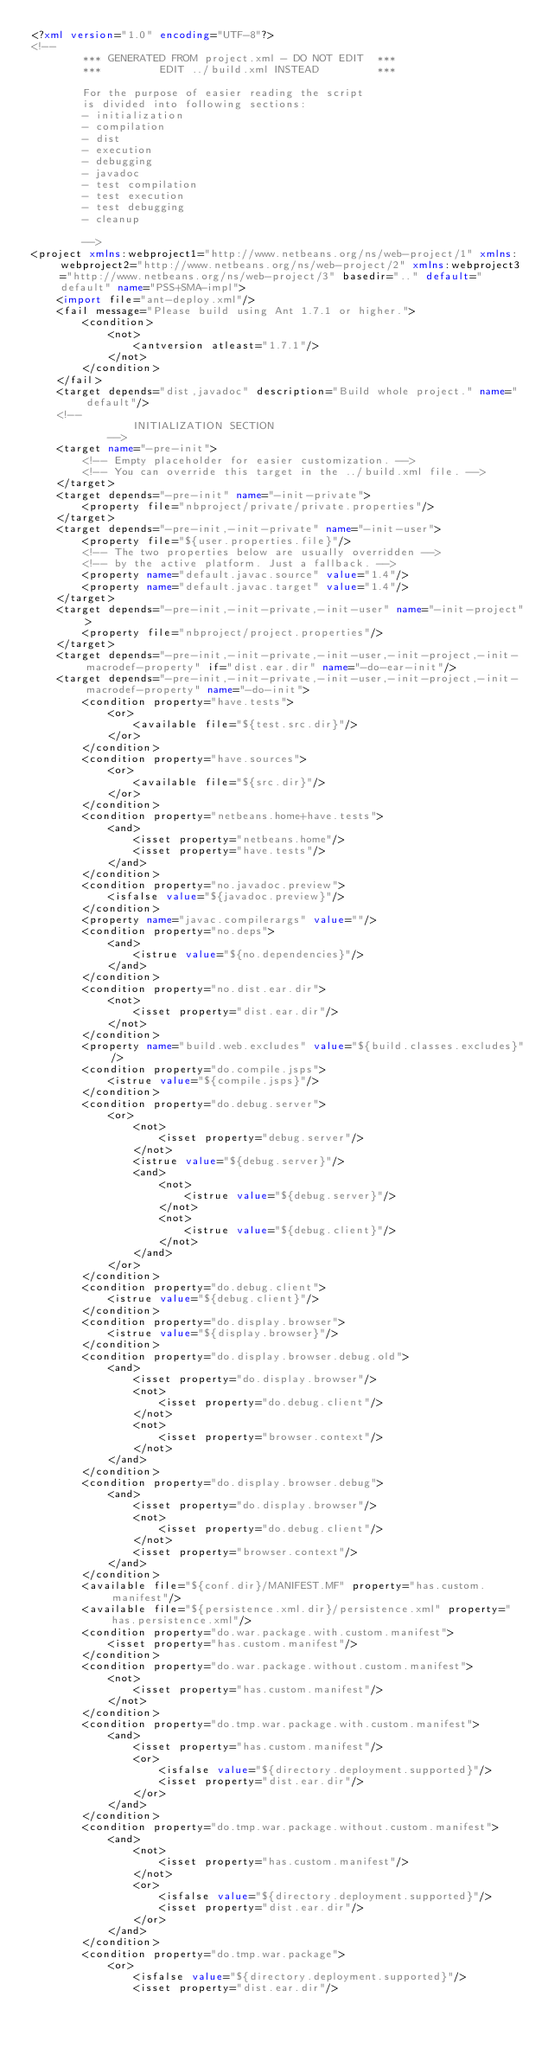<code> <loc_0><loc_0><loc_500><loc_500><_XML_><?xml version="1.0" encoding="UTF-8"?>
<!--
        *** GENERATED FROM project.xml - DO NOT EDIT  ***
        ***         EDIT ../build.xml INSTEAD         ***

        For the purpose of easier reading the script
        is divided into following sections:
        - initialization
        - compilation
        - dist
        - execution
        - debugging
        - javadoc
        - test compilation
        - test execution
        - test debugging
        - cleanup

        -->
<project xmlns:webproject1="http://www.netbeans.org/ns/web-project/1" xmlns:webproject2="http://www.netbeans.org/ns/web-project/2" xmlns:webproject3="http://www.netbeans.org/ns/web-project/3" basedir=".." default="default" name="PSS+SMA-impl">
    <import file="ant-deploy.xml"/>
    <fail message="Please build using Ant 1.7.1 or higher.">
        <condition>
            <not>
                <antversion atleast="1.7.1"/>
            </not>
        </condition>
    </fail>
    <target depends="dist,javadoc" description="Build whole project." name="default"/>
    <!--
                INITIALIZATION SECTION
            -->
    <target name="-pre-init">
        <!-- Empty placeholder for easier customization. -->
        <!-- You can override this target in the ../build.xml file. -->
    </target>
    <target depends="-pre-init" name="-init-private">
        <property file="nbproject/private/private.properties"/>
    </target>
    <target depends="-pre-init,-init-private" name="-init-user">
        <property file="${user.properties.file}"/>
        <!-- The two properties below are usually overridden -->
        <!-- by the active platform. Just a fallback. -->
        <property name="default.javac.source" value="1.4"/>
        <property name="default.javac.target" value="1.4"/>
    </target>
    <target depends="-pre-init,-init-private,-init-user" name="-init-project">
        <property file="nbproject/project.properties"/>
    </target>
    <target depends="-pre-init,-init-private,-init-user,-init-project,-init-macrodef-property" if="dist.ear.dir" name="-do-ear-init"/>
    <target depends="-pre-init,-init-private,-init-user,-init-project,-init-macrodef-property" name="-do-init">
        <condition property="have.tests">
            <or>
                <available file="${test.src.dir}"/>
            </or>
        </condition>
        <condition property="have.sources">
            <or>
                <available file="${src.dir}"/>
            </or>
        </condition>
        <condition property="netbeans.home+have.tests">
            <and>
                <isset property="netbeans.home"/>
                <isset property="have.tests"/>
            </and>
        </condition>
        <condition property="no.javadoc.preview">
            <isfalse value="${javadoc.preview}"/>
        </condition>
        <property name="javac.compilerargs" value=""/>
        <condition property="no.deps">
            <and>
                <istrue value="${no.dependencies}"/>
            </and>
        </condition>
        <condition property="no.dist.ear.dir">
            <not>
                <isset property="dist.ear.dir"/>
            </not>
        </condition>
        <property name="build.web.excludes" value="${build.classes.excludes}"/>
        <condition property="do.compile.jsps">
            <istrue value="${compile.jsps}"/>
        </condition>
        <condition property="do.debug.server">
            <or>
                <not>
                    <isset property="debug.server"/>
                </not>
                <istrue value="${debug.server}"/>
                <and>
                    <not>
                        <istrue value="${debug.server}"/>
                    </not>
                    <not>
                        <istrue value="${debug.client}"/>
                    </not>
                </and>
            </or>
        </condition>
        <condition property="do.debug.client">
            <istrue value="${debug.client}"/>
        </condition>
        <condition property="do.display.browser">
            <istrue value="${display.browser}"/>
        </condition>
        <condition property="do.display.browser.debug.old">
            <and>
                <isset property="do.display.browser"/>
                <not>
                    <isset property="do.debug.client"/>
                </not>
                <not>
                    <isset property="browser.context"/>
                </not>
            </and>
        </condition>
        <condition property="do.display.browser.debug">
            <and>
                <isset property="do.display.browser"/>
                <not>
                    <isset property="do.debug.client"/>
                </not>
                <isset property="browser.context"/>
            </and>
        </condition>
        <available file="${conf.dir}/MANIFEST.MF" property="has.custom.manifest"/>
        <available file="${persistence.xml.dir}/persistence.xml" property="has.persistence.xml"/>
        <condition property="do.war.package.with.custom.manifest">
            <isset property="has.custom.manifest"/>
        </condition>
        <condition property="do.war.package.without.custom.manifest">
            <not>
                <isset property="has.custom.manifest"/>
            </not>
        </condition>
        <condition property="do.tmp.war.package.with.custom.manifest">
            <and>
                <isset property="has.custom.manifest"/>
                <or>
                    <isfalse value="${directory.deployment.supported}"/>
                    <isset property="dist.ear.dir"/>
                </or>
            </and>
        </condition>
        <condition property="do.tmp.war.package.without.custom.manifest">
            <and>
                <not>
                    <isset property="has.custom.manifest"/>
                </not>
                <or>
                    <isfalse value="${directory.deployment.supported}"/>
                    <isset property="dist.ear.dir"/>
                </or>
            </and>
        </condition>
        <condition property="do.tmp.war.package">
            <or>
                <isfalse value="${directory.deployment.supported}"/>
                <isset property="dist.ear.dir"/></code> 